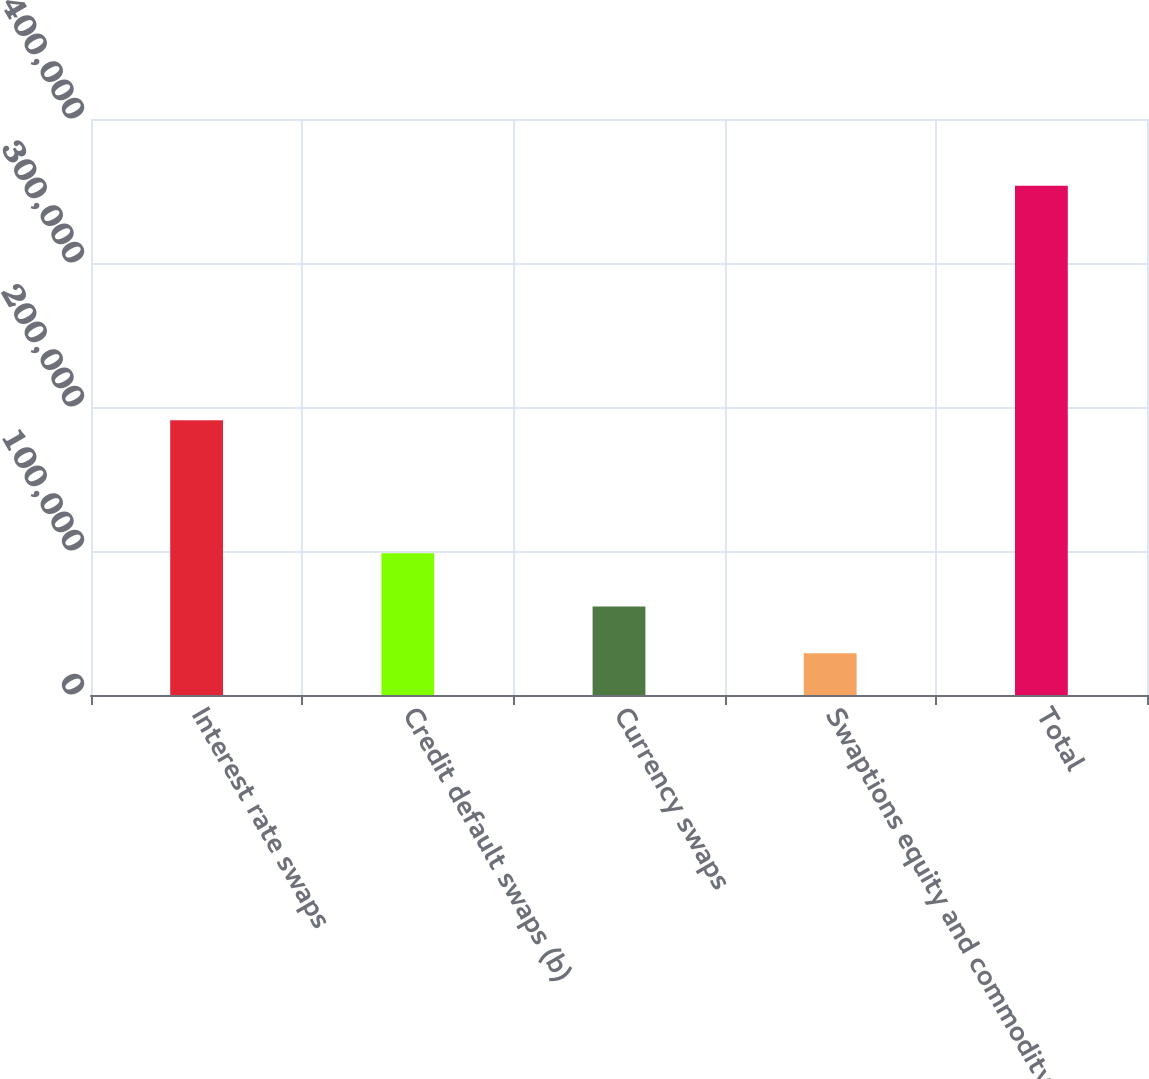Convert chart. <chart><loc_0><loc_0><loc_500><loc_500><bar_chart><fcel>Interest rate swaps<fcel>Credit default swaps (b)<fcel>Currency swaps<fcel>Swaptions equity and commodity<fcel>Total<nl><fcel>190864<fcel>98398<fcel>61383.6<fcel>28907<fcel>353673<nl></chart> 